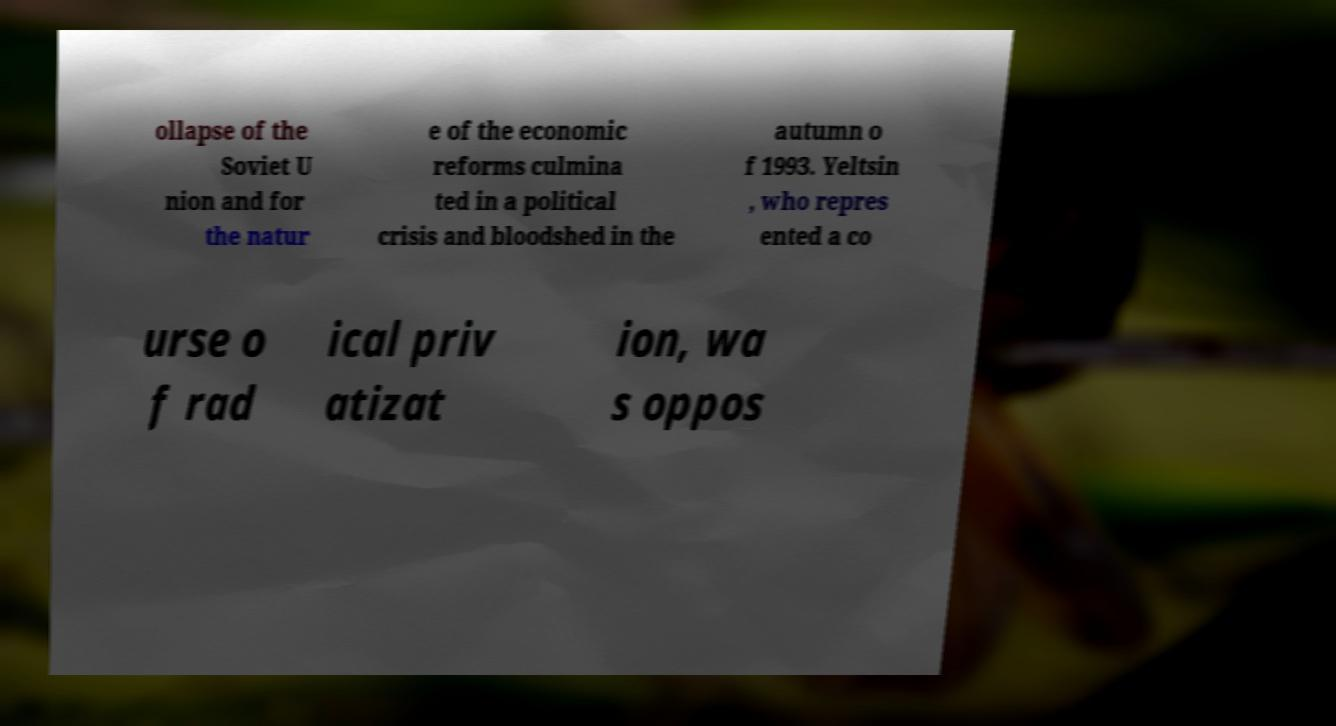Please identify and transcribe the text found in this image. ollapse of the Soviet U nion and for the natur e of the economic reforms culmina ted in a political crisis and bloodshed in the autumn o f 1993. Yeltsin , who repres ented a co urse o f rad ical priv atizat ion, wa s oppos 